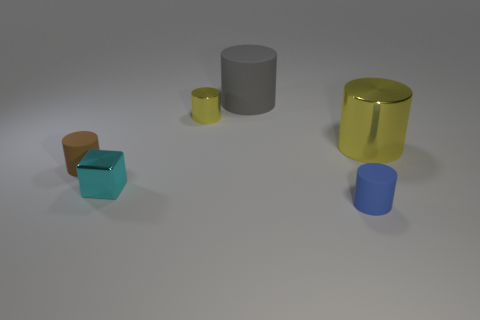Can you describe the colors and finishes of the cylinders in the image? Certainly! In the image, there are two cylinders with notably different finishes and colors. One is a large, gray cylinder with a matte finish, and the other is a smaller, glossy-finished cylinder that appears to be gold or yellow in color. 